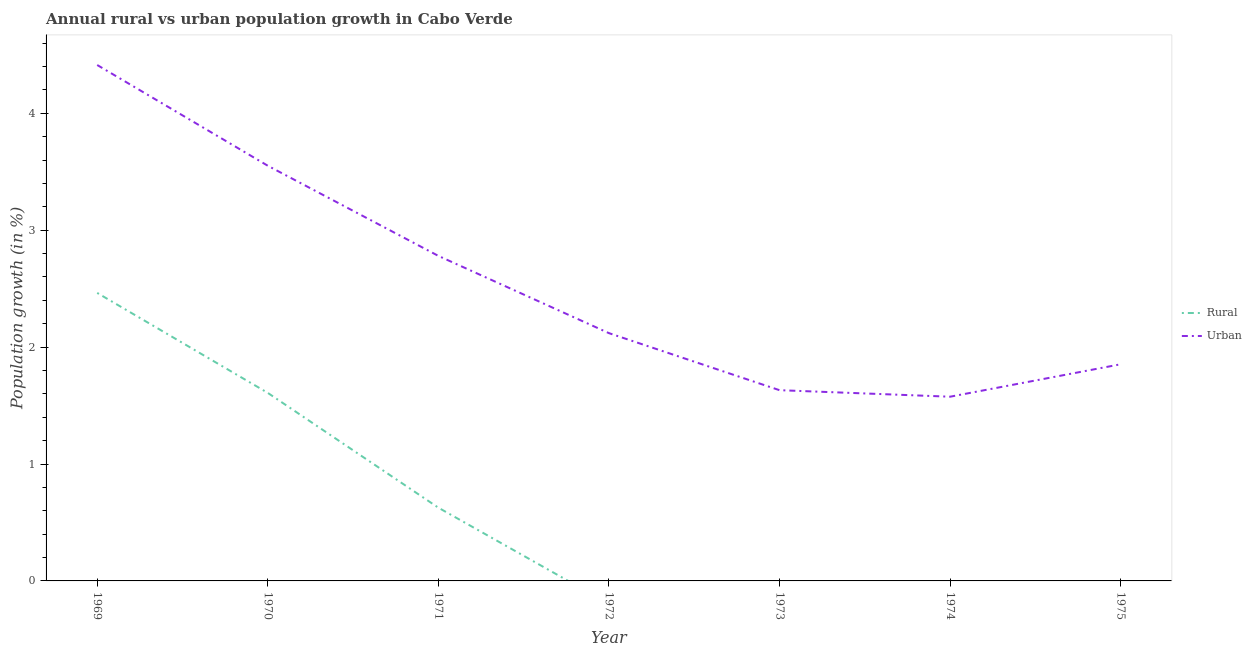Does the line corresponding to urban population growth intersect with the line corresponding to rural population growth?
Provide a succinct answer. No. Is the number of lines equal to the number of legend labels?
Ensure brevity in your answer.  No. What is the rural population growth in 1971?
Offer a very short reply. 0.63. Across all years, what is the maximum rural population growth?
Your answer should be very brief. 2.46. In which year was the rural population growth maximum?
Give a very brief answer. 1969. What is the total rural population growth in the graph?
Offer a very short reply. 4.7. What is the difference between the rural population growth in 1969 and that in 1970?
Make the answer very short. 0.86. What is the difference between the urban population growth in 1971 and the rural population growth in 1969?
Keep it short and to the point. 0.32. What is the average rural population growth per year?
Keep it short and to the point. 0.67. In the year 1969, what is the difference between the rural population growth and urban population growth?
Make the answer very short. -1.95. In how many years, is the rural population growth greater than 3 %?
Offer a terse response. 0. What is the ratio of the urban population growth in 1972 to that in 1973?
Your answer should be very brief. 1.3. Is the difference between the urban population growth in 1969 and 1970 greater than the difference between the rural population growth in 1969 and 1970?
Offer a very short reply. Yes. What is the difference between the highest and the second highest urban population growth?
Offer a terse response. 0.86. What is the difference between the highest and the lowest rural population growth?
Your answer should be very brief. 2.46. Is the sum of the urban population growth in 1969 and 1973 greater than the maximum rural population growth across all years?
Provide a short and direct response. Yes. Is the urban population growth strictly less than the rural population growth over the years?
Your response must be concise. No. How many lines are there?
Offer a very short reply. 2. How many years are there in the graph?
Provide a short and direct response. 7. Are the values on the major ticks of Y-axis written in scientific E-notation?
Offer a terse response. No. How are the legend labels stacked?
Give a very brief answer. Vertical. What is the title of the graph?
Your answer should be very brief. Annual rural vs urban population growth in Cabo Verde. What is the label or title of the Y-axis?
Your answer should be compact. Population growth (in %). What is the Population growth (in %) of Rural in 1969?
Keep it short and to the point. 2.46. What is the Population growth (in %) of Urban  in 1969?
Offer a terse response. 4.41. What is the Population growth (in %) of Rural in 1970?
Offer a terse response. 1.61. What is the Population growth (in %) in Urban  in 1970?
Offer a terse response. 3.55. What is the Population growth (in %) of Rural in 1971?
Offer a very short reply. 0.63. What is the Population growth (in %) of Urban  in 1971?
Ensure brevity in your answer.  2.78. What is the Population growth (in %) of Urban  in 1972?
Provide a succinct answer. 2.12. What is the Population growth (in %) of Rural in 1973?
Give a very brief answer. 0. What is the Population growth (in %) in Urban  in 1973?
Give a very brief answer. 1.63. What is the Population growth (in %) in Urban  in 1974?
Give a very brief answer. 1.58. What is the Population growth (in %) of Urban  in 1975?
Offer a terse response. 1.85. Across all years, what is the maximum Population growth (in %) in Rural?
Keep it short and to the point. 2.46. Across all years, what is the maximum Population growth (in %) in Urban ?
Ensure brevity in your answer.  4.41. Across all years, what is the minimum Population growth (in %) of Rural?
Offer a terse response. 0. Across all years, what is the minimum Population growth (in %) of Urban ?
Keep it short and to the point. 1.58. What is the total Population growth (in %) in Rural in the graph?
Ensure brevity in your answer.  4.7. What is the total Population growth (in %) of Urban  in the graph?
Provide a short and direct response. 17.93. What is the difference between the Population growth (in %) in Rural in 1969 and that in 1970?
Provide a short and direct response. 0.86. What is the difference between the Population growth (in %) in Urban  in 1969 and that in 1970?
Offer a very short reply. 0.86. What is the difference between the Population growth (in %) in Rural in 1969 and that in 1971?
Keep it short and to the point. 1.84. What is the difference between the Population growth (in %) of Urban  in 1969 and that in 1971?
Give a very brief answer. 1.63. What is the difference between the Population growth (in %) of Urban  in 1969 and that in 1972?
Your response must be concise. 2.29. What is the difference between the Population growth (in %) of Urban  in 1969 and that in 1973?
Provide a short and direct response. 2.78. What is the difference between the Population growth (in %) of Urban  in 1969 and that in 1974?
Your response must be concise. 2.84. What is the difference between the Population growth (in %) of Urban  in 1969 and that in 1975?
Your answer should be very brief. 2.56. What is the difference between the Population growth (in %) in Rural in 1970 and that in 1971?
Offer a terse response. 0.98. What is the difference between the Population growth (in %) of Urban  in 1970 and that in 1971?
Your answer should be very brief. 0.77. What is the difference between the Population growth (in %) in Urban  in 1970 and that in 1972?
Ensure brevity in your answer.  1.43. What is the difference between the Population growth (in %) in Urban  in 1970 and that in 1973?
Provide a succinct answer. 1.92. What is the difference between the Population growth (in %) in Urban  in 1970 and that in 1974?
Keep it short and to the point. 1.98. What is the difference between the Population growth (in %) of Urban  in 1970 and that in 1975?
Give a very brief answer. 1.7. What is the difference between the Population growth (in %) of Urban  in 1971 and that in 1972?
Your answer should be very brief. 0.66. What is the difference between the Population growth (in %) of Urban  in 1971 and that in 1973?
Your answer should be very brief. 1.15. What is the difference between the Population growth (in %) of Urban  in 1971 and that in 1974?
Your response must be concise. 1.2. What is the difference between the Population growth (in %) of Urban  in 1971 and that in 1975?
Keep it short and to the point. 0.93. What is the difference between the Population growth (in %) of Urban  in 1972 and that in 1973?
Your response must be concise. 0.49. What is the difference between the Population growth (in %) of Urban  in 1972 and that in 1974?
Provide a succinct answer. 0.54. What is the difference between the Population growth (in %) of Urban  in 1972 and that in 1975?
Provide a short and direct response. 0.27. What is the difference between the Population growth (in %) of Urban  in 1973 and that in 1974?
Give a very brief answer. 0.06. What is the difference between the Population growth (in %) in Urban  in 1973 and that in 1975?
Your response must be concise. -0.22. What is the difference between the Population growth (in %) in Urban  in 1974 and that in 1975?
Ensure brevity in your answer.  -0.28. What is the difference between the Population growth (in %) of Rural in 1969 and the Population growth (in %) of Urban  in 1970?
Provide a succinct answer. -1.09. What is the difference between the Population growth (in %) in Rural in 1969 and the Population growth (in %) in Urban  in 1971?
Your answer should be very brief. -0.32. What is the difference between the Population growth (in %) in Rural in 1969 and the Population growth (in %) in Urban  in 1972?
Your answer should be very brief. 0.34. What is the difference between the Population growth (in %) in Rural in 1969 and the Population growth (in %) in Urban  in 1973?
Provide a succinct answer. 0.83. What is the difference between the Population growth (in %) of Rural in 1969 and the Population growth (in %) of Urban  in 1974?
Your response must be concise. 0.89. What is the difference between the Population growth (in %) in Rural in 1969 and the Population growth (in %) in Urban  in 1975?
Your answer should be compact. 0.61. What is the difference between the Population growth (in %) of Rural in 1970 and the Population growth (in %) of Urban  in 1971?
Offer a very short reply. -1.17. What is the difference between the Population growth (in %) in Rural in 1970 and the Population growth (in %) in Urban  in 1972?
Your answer should be compact. -0.51. What is the difference between the Population growth (in %) of Rural in 1970 and the Population growth (in %) of Urban  in 1973?
Provide a succinct answer. -0.02. What is the difference between the Population growth (in %) in Rural in 1970 and the Population growth (in %) in Urban  in 1974?
Make the answer very short. 0.03. What is the difference between the Population growth (in %) in Rural in 1970 and the Population growth (in %) in Urban  in 1975?
Make the answer very short. -0.24. What is the difference between the Population growth (in %) of Rural in 1971 and the Population growth (in %) of Urban  in 1972?
Provide a succinct answer. -1.49. What is the difference between the Population growth (in %) of Rural in 1971 and the Population growth (in %) of Urban  in 1973?
Give a very brief answer. -1.01. What is the difference between the Population growth (in %) in Rural in 1971 and the Population growth (in %) in Urban  in 1974?
Make the answer very short. -0.95. What is the difference between the Population growth (in %) of Rural in 1971 and the Population growth (in %) of Urban  in 1975?
Your response must be concise. -1.23. What is the average Population growth (in %) in Rural per year?
Your answer should be compact. 0.67. What is the average Population growth (in %) of Urban  per year?
Your answer should be compact. 2.56. In the year 1969, what is the difference between the Population growth (in %) of Rural and Population growth (in %) of Urban ?
Offer a terse response. -1.95. In the year 1970, what is the difference between the Population growth (in %) of Rural and Population growth (in %) of Urban ?
Ensure brevity in your answer.  -1.94. In the year 1971, what is the difference between the Population growth (in %) in Rural and Population growth (in %) in Urban ?
Keep it short and to the point. -2.15. What is the ratio of the Population growth (in %) in Rural in 1969 to that in 1970?
Keep it short and to the point. 1.53. What is the ratio of the Population growth (in %) in Urban  in 1969 to that in 1970?
Provide a short and direct response. 1.24. What is the ratio of the Population growth (in %) of Rural in 1969 to that in 1971?
Offer a very short reply. 3.93. What is the ratio of the Population growth (in %) of Urban  in 1969 to that in 1971?
Your answer should be very brief. 1.59. What is the ratio of the Population growth (in %) of Urban  in 1969 to that in 1972?
Offer a very short reply. 2.08. What is the ratio of the Population growth (in %) of Urban  in 1969 to that in 1973?
Give a very brief answer. 2.7. What is the ratio of the Population growth (in %) of Urban  in 1969 to that in 1974?
Keep it short and to the point. 2.8. What is the ratio of the Population growth (in %) in Urban  in 1969 to that in 1975?
Make the answer very short. 2.38. What is the ratio of the Population growth (in %) of Rural in 1970 to that in 1971?
Keep it short and to the point. 2.57. What is the ratio of the Population growth (in %) in Urban  in 1970 to that in 1971?
Your answer should be compact. 1.28. What is the ratio of the Population growth (in %) in Urban  in 1970 to that in 1972?
Offer a terse response. 1.68. What is the ratio of the Population growth (in %) of Urban  in 1970 to that in 1973?
Your answer should be very brief. 2.18. What is the ratio of the Population growth (in %) in Urban  in 1970 to that in 1974?
Your answer should be very brief. 2.25. What is the ratio of the Population growth (in %) in Urban  in 1970 to that in 1975?
Provide a short and direct response. 1.92. What is the ratio of the Population growth (in %) of Urban  in 1971 to that in 1972?
Ensure brevity in your answer.  1.31. What is the ratio of the Population growth (in %) in Urban  in 1971 to that in 1973?
Offer a terse response. 1.7. What is the ratio of the Population growth (in %) of Urban  in 1971 to that in 1974?
Keep it short and to the point. 1.76. What is the ratio of the Population growth (in %) in Urban  in 1971 to that in 1975?
Offer a terse response. 1.5. What is the ratio of the Population growth (in %) in Urban  in 1972 to that in 1973?
Make the answer very short. 1.3. What is the ratio of the Population growth (in %) of Urban  in 1972 to that in 1974?
Ensure brevity in your answer.  1.35. What is the ratio of the Population growth (in %) of Urban  in 1972 to that in 1975?
Provide a short and direct response. 1.14. What is the ratio of the Population growth (in %) of Urban  in 1973 to that in 1974?
Provide a short and direct response. 1.04. What is the ratio of the Population growth (in %) in Urban  in 1973 to that in 1975?
Provide a succinct answer. 0.88. What is the ratio of the Population growth (in %) in Urban  in 1974 to that in 1975?
Keep it short and to the point. 0.85. What is the difference between the highest and the second highest Population growth (in %) of Rural?
Your response must be concise. 0.86. What is the difference between the highest and the second highest Population growth (in %) in Urban ?
Keep it short and to the point. 0.86. What is the difference between the highest and the lowest Population growth (in %) in Rural?
Give a very brief answer. 2.46. What is the difference between the highest and the lowest Population growth (in %) in Urban ?
Ensure brevity in your answer.  2.84. 